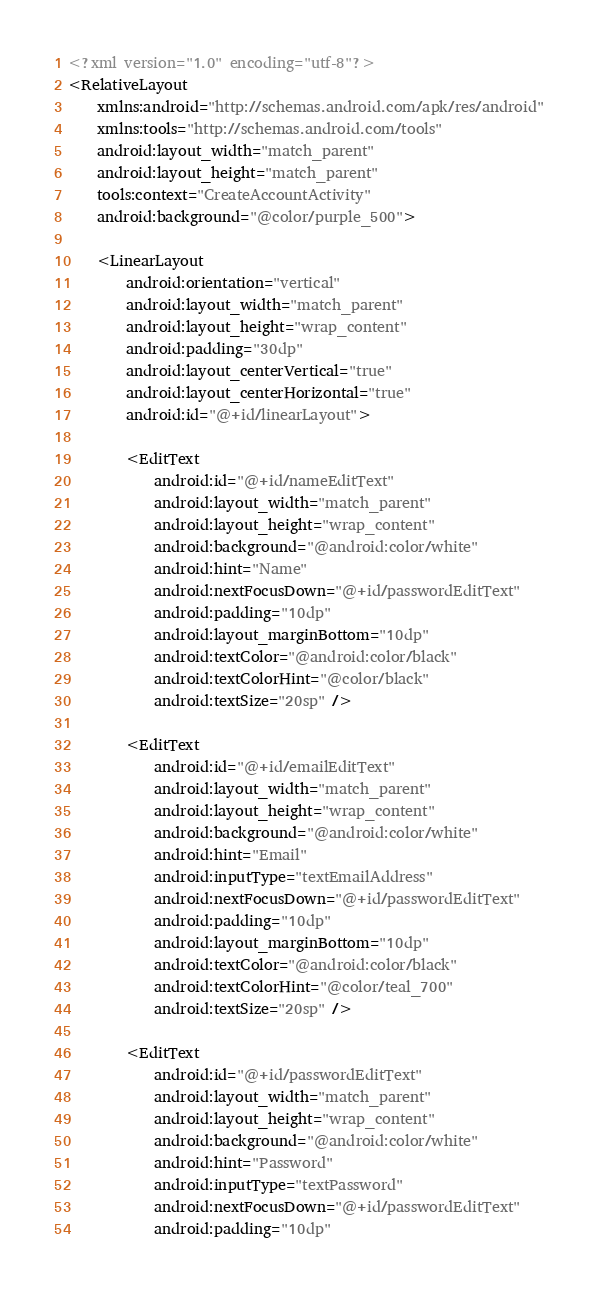<code> <loc_0><loc_0><loc_500><loc_500><_XML_><?xml version="1.0" encoding="utf-8"?>
<RelativeLayout
    xmlns:android="http://schemas.android.com/apk/res/android"
    xmlns:tools="http://schemas.android.com/tools"
    android:layout_width="match_parent"
    android:layout_height="match_parent"
    tools:context="CreateAccountActivity"
    android:background="@color/purple_500">

    <LinearLayout
        android:orientation="vertical"
        android:layout_width="match_parent"
        android:layout_height="wrap_content"
        android:padding="30dp"
        android:layout_centerVertical="true"
        android:layout_centerHorizontal="true"
        android:id="@+id/linearLayout">

        <EditText
            android:id="@+id/nameEditText"
            android:layout_width="match_parent"
            android:layout_height="wrap_content"
            android:background="@android:color/white"
            android:hint="Name"
            android:nextFocusDown="@+id/passwordEditText"
            android:padding="10dp"
            android:layout_marginBottom="10dp"
            android:textColor="@android:color/black"
            android:textColorHint="@color/black"
            android:textSize="20sp" />

        <EditText
            android:id="@+id/emailEditText"
            android:layout_width="match_parent"
            android:layout_height="wrap_content"
            android:background="@android:color/white"
            android:hint="Email"
            android:inputType="textEmailAddress"
            android:nextFocusDown="@+id/passwordEditText"
            android:padding="10dp"
            android:layout_marginBottom="10dp"
            android:textColor="@android:color/black"
            android:textColorHint="@color/teal_700"
            android:textSize="20sp" />

        <EditText
            android:id="@+id/passwordEditText"
            android:layout_width="match_parent"
            android:layout_height="wrap_content"
            android:background="@android:color/white"
            android:hint="Password"
            android:inputType="textPassword"
            android:nextFocusDown="@+id/passwordEditText"
            android:padding="10dp"</code> 